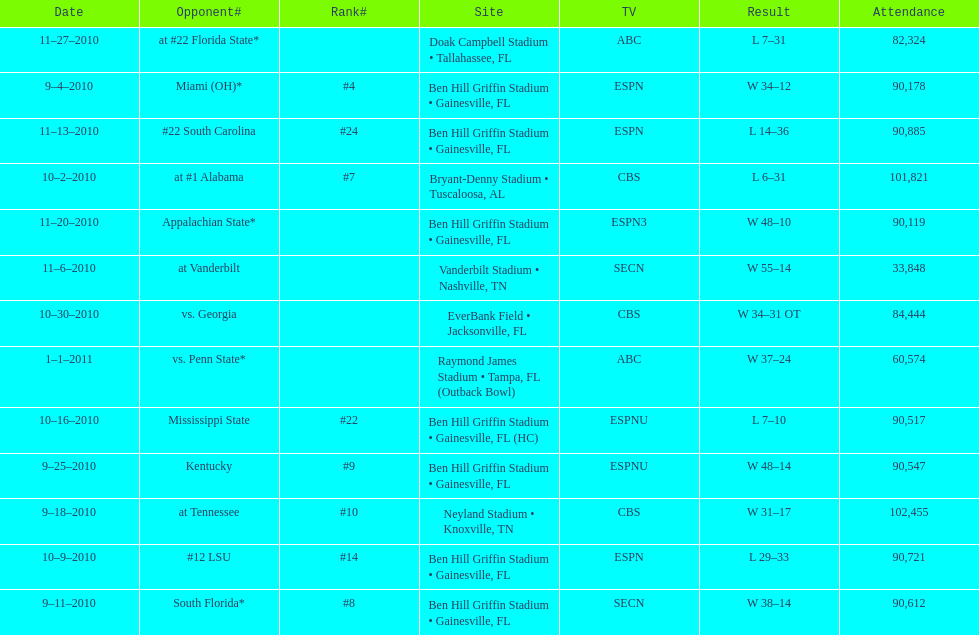How many consecutive weeks did the the gators win until the had their first lost in the 2010 season? 4. 